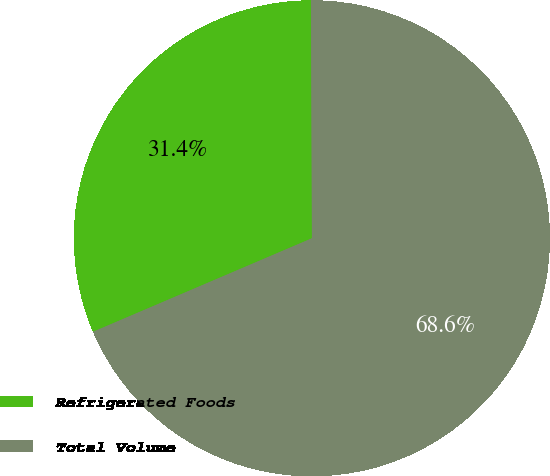<chart> <loc_0><loc_0><loc_500><loc_500><pie_chart><fcel>Refrigerated Foods<fcel>Total Volume<nl><fcel>31.37%<fcel>68.63%<nl></chart> 